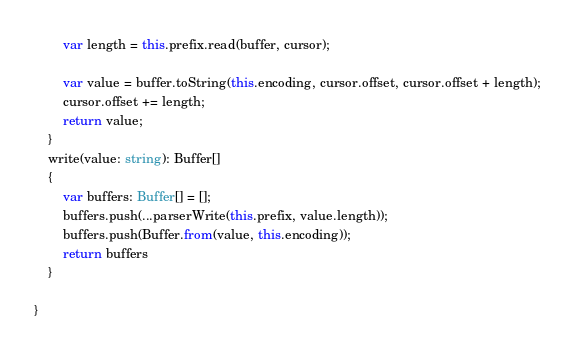Convert code to text. <code><loc_0><loc_0><loc_500><loc_500><_TypeScript_>
        var length = this.prefix.read(buffer, cursor);

        var value = buffer.toString(this.encoding, cursor.offset, cursor.offset + length);
        cursor.offset += length;
        return value;
    }
    write(value: string): Buffer[]
    {
        var buffers: Buffer[] = [];
        buffers.push(...parserWrite(this.prefix, value.length));
        buffers.push(Buffer.from(value, this.encoding));
        return buffers
    }

}</code> 